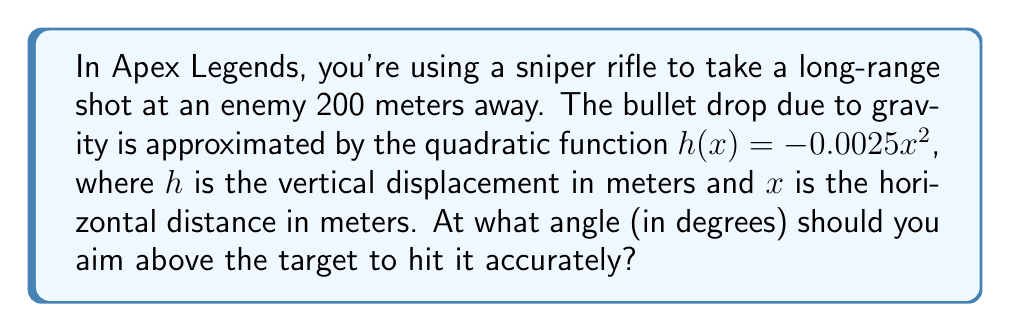Can you solve this math problem? Let's approach this step-by-step:

1) The bullet drop function is given by $h(x) = -0.0025x^2$.

2) We need to find the angle that compensates for this drop at a distance of 200 meters.

3) First, let's calculate the vertical drop at 200 meters:
   $h(200) = -0.0025(200)^2 = -100$ meters

4) This means we need to aim 100 meters above the target at a distance of 200 meters.

5) We can visualize this as a right triangle, where:
   - The base is 200 meters (horizontal distance)
   - The height is 100 meters (vertical compensation)
   - The hypotenuse is the line of sight

6) To find the angle, we can use the tangent function:

   $\tan(\theta) = \frac{\text{opposite}}{\text{adjacent}} = \frac{100}{200} = 0.5$

7) To get the angle, we need to take the inverse tangent (arctan):

   $\theta = \arctan(0.5)$

8) Converting this to degrees:

   $\theta = \arctan(0.5) \cdot \frac{180}{\pi} \approx 26.57°$

[asy]
unitsize(0.02cm);
draw((0,0)--(200,0)--(200,100)--(0,0));
label("200m", (100,-10));
label("100m", (210,50));
label("θ", (10,10));
draw((0,0)--(20,10), arrow=Arrow(TeXHead));
[/asy]
Answer: The optimal angle to aim above the target is approximately $26.57°$. 